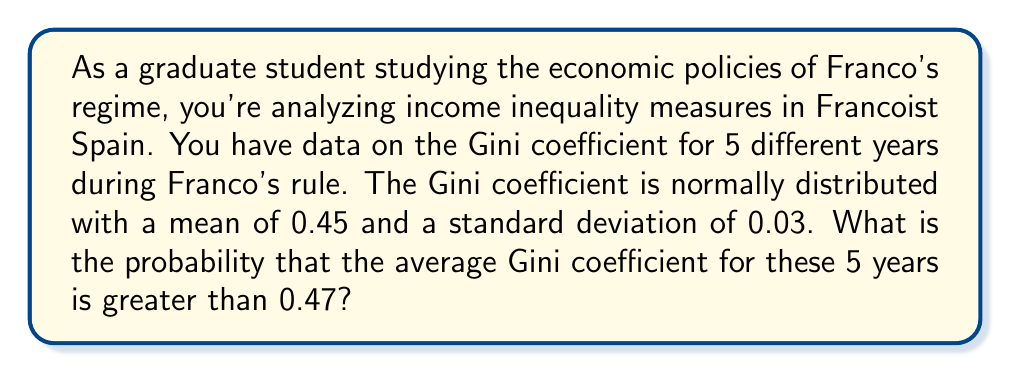Can you solve this math problem? To solve this problem, we need to follow these steps:

1) First, recall that the Gini coefficient is a measure of income inequality, ranging from 0 (perfect equality) to 1 (perfect inequality).

2) We are given that the Gini coefficient is normally distributed with:
   $\mu = 0.45$ (mean)
   $\sigma = 0.03$ (standard deviation)

3) We want to find the probability that the average of 5 Gini coefficients is greater than 0.47.

4) The sampling distribution of the mean for n=5 will also be normally distributed with:
   $\mu_{\bar{x}} = \mu = 0.45$
   $\sigma_{\bar{x}} = \frac{\sigma}{\sqrt{n}} = \frac{0.03}{\sqrt{5}} = 0.0134$

5) We can standardize our value of interest (0.47) to a z-score:

   $$z = \frac{\bar{x} - \mu_{\bar{x}}}{\sigma_{\bar{x}}} = \frac{0.47 - 0.45}{0.0134} = 1.49$$

6) We want the probability of being greater than this z-score. In a standard normal distribution, this is the area to the right of z = 1.49.

7) Using a standard normal table or calculator, we can find:
   $P(Z > 1.49) = 1 - P(Z < 1.49) = 1 - 0.9319 = 0.0681$

Therefore, the probability that the average Gini coefficient for these 5 years is greater than 0.47 is approximately 0.0681 or 6.81%.
Answer: 0.0681 or 6.81% 